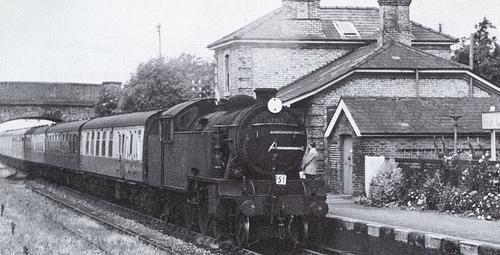How many trains are there?
Give a very brief answer. 1. 